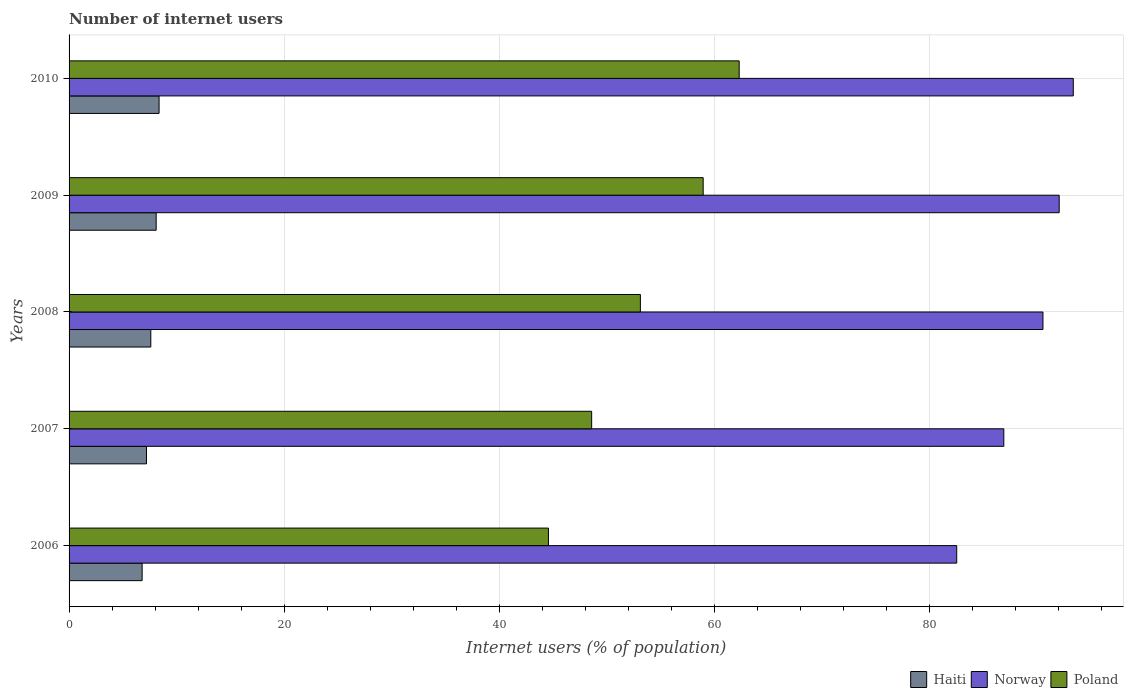How many different coloured bars are there?
Keep it short and to the point. 3. How many groups of bars are there?
Your answer should be very brief. 5. What is the label of the 4th group of bars from the top?
Keep it short and to the point. 2007. Across all years, what is the maximum number of internet users in Poland?
Offer a terse response. 62.32. Across all years, what is the minimum number of internet users in Norway?
Your answer should be compact. 82.55. What is the total number of internet users in Haiti in the graph?
Offer a terse response. 38.07. What is the difference between the number of internet users in Haiti in 2006 and that in 2007?
Keep it short and to the point. -0.4. What is the difference between the number of internet users in Poland in 2008 and the number of internet users in Norway in 2007?
Your response must be concise. -33.8. What is the average number of internet users in Norway per year?
Offer a very short reply. 89.1. In the year 2007, what is the difference between the number of internet users in Poland and number of internet users in Norway?
Your answer should be very brief. -38.33. What is the ratio of the number of internet users in Haiti in 2009 to that in 2010?
Keep it short and to the point. 0.97. What is the difference between the highest and the second highest number of internet users in Haiti?
Provide a succinct answer. 0.27. What is the difference between the highest and the lowest number of internet users in Norway?
Provide a succinct answer. 10.84. Is the sum of the number of internet users in Norway in 2007 and 2010 greater than the maximum number of internet users in Haiti across all years?
Make the answer very short. Yes. What does the 3rd bar from the top in 2007 represents?
Provide a short and direct response. Haiti. What does the 1st bar from the bottom in 2008 represents?
Ensure brevity in your answer.  Haiti. How many years are there in the graph?
Your response must be concise. 5. What is the difference between two consecutive major ticks on the X-axis?
Keep it short and to the point. 20. Does the graph contain any zero values?
Your answer should be very brief. No. Does the graph contain grids?
Your answer should be compact. Yes. How are the legend labels stacked?
Provide a short and direct response. Horizontal. What is the title of the graph?
Offer a very short reply. Number of internet users. What is the label or title of the X-axis?
Ensure brevity in your answer.  Internet users (% of population). What is the Internet users (% of population) in Haiti in 2006?
Offer a very short reply. 6.8. What is the Internet users (% of population) in Norway in 2006?
Keep it short and to the point. 82.55. What is the Internet users (% of population) of Poland in 2006?
Give a very brief answer. 44.58. What is the Internet users (% of population) of Norway in 2007?
Your answer should be very brief. 86.93. What is the Internet users (% of population) in Poland in 2007?
Keep it short and to the point. 48.6. What is the Internet users (% of population) of Norway in 2008?
Offer a terse response. 90.57. What is the Internet users (% of population) in Poland in 2008?
Your answer should be compact. 53.13. What is the Internet users (% of population) of Norway in 2009?
Your response must be concise. 92.08. What is the Internet users (% of population) of Poland in 2009?
Offer a very short reply. 58.97. What is the Internet users (% of population) of Haiti in 2010?
Ensure brevity in your answer.  8.37. What is the Internet users (% of population) in Norway in 2010?
Keep it short and to the point. 93.39. What is the Internet users (% of population) in Poland in 2010?
Your response must be concise. 62.32. Across all years, what is the maximum Internet users (% of population) in Haiti?
Make the answer very short. 8.37. Across all years, what is the maximum Internet users (% of population) of Norway?
Your response must be concise. 93.39. Across all years, what is the maximum Internet users (% of population) in Poland?
Offer a terse response. 62.32. Across all years, what is the minimum Internet users (% of population) of Haiti?
Your answer should be very brief. 6.8. Across all years, what is the minimum Internet users (% of population) of Norway?
Your answer should be very brief. 82.55. Across all years, what is the minimum Internet users (% of population) of Poland?
Offer a terse response. 44.58. What is the total Internet users (% of population) of Haiti in the graph?
Make the answer very short. 38.07. What is the total Internet users (% of population) of Norway in the graph?
Offer a very short reply. 445.52. What is the total Internet users (% of population) in Poland in the graph?
Provide a short and direct response. 267.6. What is the difference between the Internet users (% of population) in Haiti in 2006 and that in 2007?
Give a very brief answer. -0.4. What is the difference between the Internet users (% of population) of Norway in 2006 and that in 2007?
Provide a short and direct response. -4.38. What is the difference between the Internet users (% of population) of Poland in 2006 and that in 2007?
Keep it short and to the point. -4.02. What is the difference between the Internet users (% of population) in Haiti in 2006 and that in 2008?
Your answer should be compact. -0.8. What is the difference between the Internet users (% of population) in Norway in 2006 and that in 2008?
Make the answer very short. -8.02. What is the difference between the Internet users (% of population) in Poland in 2006 and that in 2008?
Give a very brief answer. -8.55. What is the difference between the Internet users (% of population) in Haiti in 2006 and that in 2009?
Provide a succinct answer. -1.3. What is the difference between the Internet users (% of population) in Norway in 2006 and that in 2009?
Offer a very short reply. -9.53. What is the difference between the Internet users (% of population) in Poland in 2006 and that in 2009?
Provide a succinct answer. -14.39. What is the difference between the Internet users (% of population) of Haiti in 2006 and that in 2010?
Your answer should be compact. -1.57. What is the difference between the Internet users (% of population) of Norway in 2006 and that in 2010?
Offer a terse response. -10.84. What is the difference between the Internet users (% of population) in Poland in 2006 and that in 2010?
Your answer should be very brief. -17.74. What is the difference between the Internet users (% of population) in Norway in 2007 and that in 2008?
Your answer should be very brief. -3.64. What is the difference between the Internet users (% of population) in Poland in 2007 and that in 2008?
Give a very brief answer. -4.53. What is the difference between the Internet users (% of population) in Haiti in 2007 and that in 2009?
Offer a very short reply. -0.9. What is the difference between the Internet users (% of population) of Norway in 2007 and that in 2009?
Make the answer very short. -5.15. What is the difference between the Internet users (% of population) in Poland in 2007 and that in 2009?
Your response must be concise. -10.37. What is the difference between the Internet users (% of population) of Haiti in 2007 and that in 2010?
Provide a succinct answer. -1.17. What is the difference between the Internet users (% of population) in Norway in 2007 and that in 2010?
Keep it short and to the point. -6.46. What is the difference between the Internet users (% of population) in Poland in 2007 and that in 2010?
Make the answer very short. -13.72. What is the difference between the Internet users (% of population) of Norway in 2008 and that in 2009?
Keep it short and to the point. -1.51. What is the difference between the Internet users (% of population) of Poland in 2008 and that in 2009?
Provide a short and direct response. -5.84. What is the difference between the Internet users (% of population) in Haiti in 2008 and that in 2010?
Your answer should be compact. -0.77. What is the difference between the Internet users (% of population) in Norway in 2008 and that in 2010?
Give a very brief answer. -2.82. What is the difference between the Internet users (% of population) of Poland in 2008 and that in 2010?
Offer a terse response. -9.19. What is the difference between the Internet users (% of population) of Haiti in 2009 and that in 2010?
Provide a succinct answer. -0.27. What is the difference between the Internet users (% of population) in Norway in 2009 and that in 2010?
Keep it short and to the point. -1.31. What is the difference between the Internet users (% of population) of Poland in 2009 and that in 2010?
Your answer should be compact. -3.35. What is the difference between the Internet users (% of population) of Haiti in 2006 and the Internet users (% of population) of Norway in 2007?
Your answer should be very brief. -80.13. What is the difference between the Internet users (% of population) of Haiti in 2006 and the Internet users (% of population) of Poland in 2007?
Provide a short and direct response. -41.8. What is the difference between the Internet users (% of population) of Norway in 2006 and the Internet users (% of population) of Poland in 2007?
Offer a very short reply. 33.95. What is the difference between the Internet users (% of population) in Haiti in 2006 and the Internet users (% of population) in Norway in 2008?
Give a very brief answer. -83.77. What is the difference between the Internet users (% of population) in Haiti in 2006 and the Internet users (% of population) in Poland in 2008?
Give a very brief answer. -46.33. What is the difference between the Internet users (% of population) in Norway in 2006 and the Internet users (% of population) in Poland in 2008?
Your answer should be very brief. 29.42. What is the difference between the Internet users (% of population) of Haiti in 2006 and the Internet users (% of population) of Norway in 2009?
Your answer should be compact. -85.28. What is the difference between the Internet users (% of population) of Haiti in 2006 and the Internet users (% of population) of Poland in 2009?
Make the answer very short. -52.17. What is the difference between the Internet users (% of population) of Norway in 2006 and the Internet users (% of population) of Poland in 2009?
Offer a terse response. 23.58. What is the difference between the Internet users (% of population) in Haiti in 2006 and the Internet users (% of population) in Norway in 2010?
Give a very brief answer. -86.59. What is the difference between the Internet users (% of population) of Haiti in 2006 and the Internet users (% of population) of Poland in 2010?
Give a very brief answer. -55.52. What is the difference between the Internet users (% of population) in Norway in 2006 and the Internet users (% of population) in Poland in 2010?
Ensure brevity in your answer.  20.23. What is the difference between the Internet users (% of population) in Haiti in 2007 and the Internet users (% of population) in Norway in 2008?
Give a very brief answer. -83.37. What is the difference between the Internet users (% of population) in Haiti in 2007 and the Internet users (% of population) in Poland in 2008?
Offer a very short reply. -45.93. What is the difference between the Internet users (% of population) of Norway in 2007 and the Internet users (% of population) of Poland in 2008?
Your response must be concise. 33.8. What is the difference between the Internet users (% of population) of Haiti in 2007 and the Internet users (% of population) of Norway in 2009?
Ensure brevity in your answer.  -84.88. What is the difference between the Internet users (% of population) in Haiti in 2007 and the Internet users (% of population) in Poland in 2009?
Provide a succinct answer. -51.77. What is the difference between the Internet users (% of population) of Norway in 2007 and the Internet users (% of population) of Poland in 2009?
Offer a terse response. 27.96. What is the difference between the Internet users (% of population) of Haiti in 2007 and the Internet users (% of population) of Norway in 2010?
Your response must be concise. -86.19. What is the difference between the Internet users (% of population) of Haiti in 2007 and the Internet users (% of population) of Poland in 2010?
Offer a very short reply. -55.12. What is the difference between the Internet users (% of population) of Norway in 2007 and the Internet users (% of population) of Poland in 2010?
Offer a terse response. 24.61. What is the difference between the Internet users (% of population) in Haiti in 2008 and the Internet users (% of population) in Norway in 2009?
Provide a short and direct response. -84.48. What is the difference between the Internet users (% of population) of Haiti in 2008 and the Internet users (% of population) of Poland in 2009?
Keep it short and to the point. -51.37. What is the difference between the Internet users (% of population) in Norway in 2008 and the Internet users (% of population) in Poland in 2009?
Provide a short and direct response. 31.6. What is the difference between the Internet users (% of population) in Haiti in 2008 and the Internet users (% of population) in Norway in 2010?
Your response must be concise. -85.79. What is the difference between the Internet users (% of population) of Haiti in 2008 and the Internet users (% of population) of Poland in 2010?
Your response must be concise. -54.72. What is the difference between the Internet users (% of population) of Norway in 2008 and the Internet users (% of population) of Poland in 2010?
Your answer should be very brief. 28.25. What is the difference between the Internet users (% of population) of Haiti in 2009 and the Internet users (% of population) of Norway in 2010?
Make the answer very short. -85.29. What is the difference between the Internet users (% of population) in Haiti in 2009 and the Internet users (% of population) in Poland in 2010?
Offer a terse response. -54.22. What is the difference between the Internet users (% of population) of Norway in 2009 and the Internet users (% of population) of Poland in 2010?
Give a very brief answer. 29.76. What is the average Internet users (% of population) of Haiti per year?
Offer a terse response. 7.61. What is the average Internet users (% of population) of Norway per year?
Your answer should be compact. 89.1. What is the average Internet users (% of population) of Poland per year?
Ensure brevity in your answer.  53.52. In the year 2006, what is the difference between the Internet users (% of population) of Haiti and Internet users (% of population) of Norway?
Your response must be concise. -75.75. In the year 2006, what is the difference between the Internet users (% of population) of Haiti and Internet users (% of population) of Poland?
Your answer should be very brief. -37.78. In the year 2006, what is the difference between the Internet users (% of population) in Norway and Internet users (% of population) in Poland?
Offer a very short reply. 37.97. In the year 2007, what is the difference between the Internet users (% of population) in Haiti and Internet users (% of population) in Norway?
Ensure brevity in your answer.  -79.73. In the year 2007, what is the difference between the Internet users (% of population) in Haiti and Internet users (% of population) in Poland?
Ensure brevity in your answer.  -41.4. In the year 2007, what is the difference between the Internet users (% of population) in Norway and Internet users (% of population) in Poland?
Provide a succinct answer. 38.33. In the year 2008, what is the difference between the Internet users (% of population) in Haiti and Internet users (% of population) in Norway?
Make the answer very short. -82.97. In the year 2008, what is the difference between the Internet users (% of population) of Haiti and Internet users (% of population) of Poland?
Give a very brief answer. -45.53. In the year 2008, what is the difference between the Internet users (% of population) in Norway and Internet users (% of population) in Poland?
Your answer should be compact. 37.44. In the year 2009, what is the difference between the Internet users (% of population) in Haiti and Internet users (% of population) in Norway?
Offer a terse response. -83.98. In the year 2009, what is the difference between the Internet users (% of population) of Haiti and Internet users (% of population) of Poland?
Your answer should be compact. -50.87. In the year 2009, what is the difference between the Internet users (% of population) in Norway and Internet users (% of population) in Poland?
Ensure brevity in your answer.  33.11. In the year 2010, what is the difference between the Internet users (% of population) of Haiti and Internet users (% of population) of Norway?
Give a very brief answer. -85.02. In the year 2010, what is the difference between the Internet users (% of population) of Haiti and Internet users (% of population) of Poland?
Make the answer very short. -53.95. In the year 2010, what is the difference between the Internet users (% of population) in Norway and Internet users (% of population) in Poland?
Your answer should be compact. 31.07. What is the ratio of the Internet users (% of population) of Haiti in 2006 to that in 2007?
Your answer should be very brief. 0.94. What is the ratio of the Internet users (% of population) in Norway in 2006 to that in 2007?
Ensure brevity in your answer.  0.95. What is the ratio of the Internet users (% of population) in Poland in 2006 to that in 2007?
Your answer should be very brief. 0.92. What is the ratio of the Internet users (% of population) of Haiti in 2006 to that in 2008?
Give a very brief answer. 0.89. What is the ratio of the Internet users (% of population) in Norway in 2006 to that in 2008?
Keep it short and to the point. 0.91. What is the ratio of the Internet users (% of population) of Poland in 2006 to that in 2008?
Your answer should be very brief. 0.84. What is the ratio of the Internet users (% of population) in Haiti in 2006 to that in 2009?
Offer a very short reply. 0.84. What is the ratio of the Internet users (% of population) in Norway in 2006 to that in 2009?
Provide a succinct answer. 0.9. What is the ratio of the Internet users (% of population) in Poland in 2006 to that in 2009?
Ensure brevity in your answer.  0.76. What is the ratio of the Internet users (% of population) of Haiti in 2006 to that in 2010?
Provide a succinct answer. 0.81. What is the ratio of the Internet users (% of population) in Norway in 2006 to that in 2010?
Provide a succinct answer. 0.88. What is the ratio of the Internet users (% of population) of Poland in 2006 to that in 2010?
Your answer should be compact. 0.72. What is the ratio of the Internet users (% of population) of Haiti in 2007 to that in 2008?
Keep it short and to the point. 0.95. What is the ratio of the Internet users (% of population) in Norway in 2007 to that in 2008?
Ensure brevity in your answer.  0.96. What is the ratio of the Internet users (% of population) in Poland in 2007 to that in 2008?
Offer a very short reply. 0.91. What is the ratio of the Internet users (% of population) of Haiti in 2007 to that in 2009?
Provide a succinct answer. 0.89. What is the ratio of the Internet users (% of population) of Norway in 2007 to that in 2009?
Your answer should be compact. 0.94. What is the ratio of the Internet users (% of population) of Poland in 2007 to that in 2009?
Your response must be concise. 0.82. What is the ratio of the Internet users (% of population) of Haiti in 2007 to that in 2010?
Provide a short and direct response. 0.86. What is the ratio of the Internet users (% of population) in Norway in 2007 to that in 2010?
Offer a terse response. 0.93. What is the ratio of the Internet users (% of population) in Poland in 2007 to that in 2010?
Provide a succinct answer. 0.78. What is the ratio of the Internet users (% of population) in Haiti in 2008 to that in 2009?
Give a very brief answer. 0.94. What is the ratio of the Internet users (% of population) of Norway in 2008 to that in 2009?
Your answer should be very brief. 0.98. What is the ratio of the Internet users (% of population) in Poland in 2008 to that in 2009?
Offer a terse response. 0.9. What is the ratio of the Internet users (% of population) in Haiti in 2008 to that in 2010?
Offer a terse response. 0.91. What is the ratio of the Internet users (% of population) of Norway in 2008 to that in 2010?
Ensure brevity in your answer.  0.97. What is the ratio of the Internet users (% of population) in Poland in 2008 to that in 2010?
Keep it short and to the point. 0.85. What is the ratio of the Internet users (% of population) in Poland in 2009 to that in 2010?
Make the answer very short. 0.95. What is the difference between the highest and the second highest Internet users (% of population) in Haiti?
Provide a succinct answer. 0.27. What is the difference between the highest and the second highest Internet users (% of population) in Norway?
Keep it short and to the point. 1.31. What is the difference between the highest and the second highest Internet users (% of population) of Poland?
Provide a succinct answer. 3.35. What is the difference between the highest and the lowest Internet users (% of population) in Haiti?
Provide a succinct answer. 1.57. What is the difference between the highest and the lowest Internet users (% of population) in Norway?
Your answer should be compact. 10.84. What is the difference between the highest and the lowest Internet users (% of population) of Poland?
Your response must be concise. 17.74. 